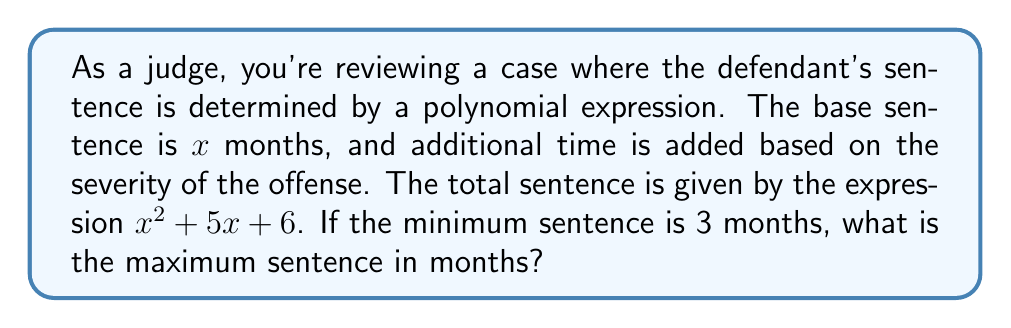Can you answer this question? To solve this problem, we need to follow these steps:

1) First, we need to factor the polynomial $x^2 + 5x + 6$. This is a quadratic expression in the form $ax^2 + bx + c$, where $a=1$, $b=5$, and $c=6$.

2) To factor this, we look for two numbers that multiply to give $ac = 1 \times 6 = 6$ and add up to $b = 5$. These numbers are 2 and 3.

3) We can rewrite the middle term as: $x^2 + 2x + 3x + 6$

4) Now we can factor by grouping:
   $$(x^2 + 2x) + (3x + 6)$$
   $$x(x + 2) + 3(x + 2)$$
   $$(x + 3)(x + 2)$$

5) So, the factored form of the sentence expression is $(x + 3)(x + 2)$

6) We're told that the minimum sentence is 3 months. This means that $x = 0$ in this case, as the base sentence of $x$ months plus the additional 3 months equals the minimum sentence.

7) To find the maximum sentence, we need to find the largest possible value for $x$. In a quadratic expression like this, the largest value occurs at the larger root of the equation.

8) The roots of the equation $(x + 3)(x + 2) = 0$ are $x = -3$ and $x = -2$

9) Since sentences can't be negative, the maximum value for $x$ is the larger of these two roots when they're positive, which is $x = 0$

10) Therefore, the maximum sentence occurs when $x = 0$, and is equal to:

    $$0^2 + 5(0) + 6 = 6$$ months
Answer: The maximum sentence is 6 months. 